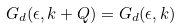<formula> <loc_0><loc_0><loc_500><loc_500>G _ { d } ( \epsilon , { k + Q } ) = G _ { d } ( \epsilon , { k } )</formula> 